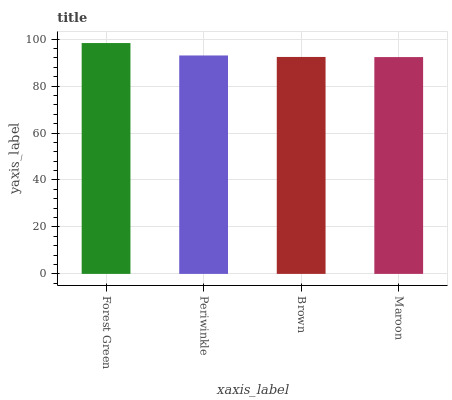Is Periwinkle the minimum?
Answer yes or no. No. Is Periwinkle the maximum?
Answer yes or no. No. Is Forest Green greater than Periwinkle?
Answer yes or no. Yes. Is Periwinkle less than Forest Green?
Answer yes or no. Yes. Is Periwinkle greater than Forest Green?
Answer yes or no. No. Is Forest Green less than Periwinkle?
Answer yes or no. No. Is Periwinkle the high median?
Answer yes or no. Yes. Is Brown the low median?
Answer yes or no. Yes. Is Brown the high median?
Answer yes or no. No. Is Forest Green the low median?
Answer yes or no. No. 